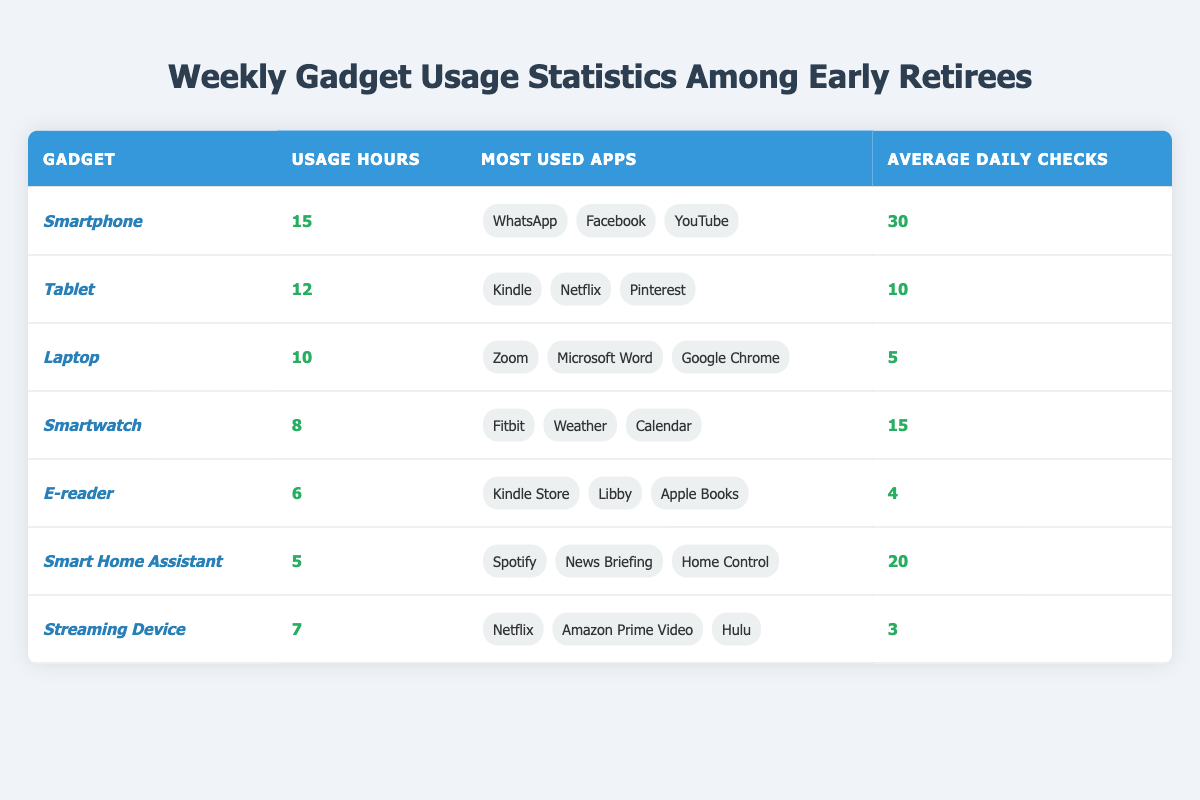What gadget has the highest usage hours? The gadget with the highest usage hours can be found in the first column of the table. Looking at the "Usage Hours" column, the smartphone has the highest value at 15 hours.
Answer: Smartphone How many average daily checks do users perform on their tablets? The average daily checks for tablets is listed in the last column of the tablet row. It shows an average of 10 daily checks for tablets.
Answer: 10 What are the most used apps for Smartwatches? The most used apps can be found in the "Most Used Apps" column for Smartwatches. The apps listed are Fitbit, Weather, and Calendar.
Answer: Fitbit, Weather, Calendar Which gadget has fewer usage hours than the Smart Home Assistant? The usage hours for Smart Home Assistant are 5. We check each gadget's usage hours, and the E-reader (6 hours) and Streaming Device (7 hours) have more hours, while the Laptop (10), Tablet (12), and Smartphone (15) have more usage hours. Only the Smart Home Assistant has fewer usage hours than 5.
Answer: No gadgets What is the total usage hours for all gadgets listed? We sum up the usage hours of all gadgets: 15 (Smartphone) + 12 (Tablet) + 10 (Laptop) + 8 (Smartwatch) + 6 (E-reader) + 5 (Smart Home Assistant) + 7 (Streaming Device) = 63 hours total.
Answer: 63 Which gadget has the lowest average daily checks, and what is that number? We look at the "Average Daily Checks" column to find the lowest number. The Streaming Device has the lowest average daily checks at 3.
Answer: Streaming Device, 3 Is it true that the most used app for the Tablet is Netflix? We check the "Most Used Apps" for the Tablet. The first app listed is Kindle, not Netflix, making the statement false.
Answer: No Calculate the average usage hours for all gadgets. The total usage hours are 63 (calculated previously). There are 7 gadgets, so we divide 63 by 7, which equals approximately 9 hours.
Answer: 9 What is the difference in average daily checks between the Smartphone and the E-reader? The average daily checks for the Smartphone are 30 and for the E-reader are 4. To find the difference, we subtract: 30 - 4 = 26.
Answer: 26 Which gadget is used for video streaming based on the most used apps? In the "Most Used Apps" column, both the Tablet and Streaming Device list apps used for video streaming, such as Netflix and Amazon Prime Video. They are video streaming gadgets.
Answer: Tablet, Streaming Device How many gadgets have an average usage of more than 10 hours? Checking the "Usage Hours" column, the Smartphone (15), Tablet (12), and Laptop (10) are those with more than 10 hours, totaling three gadgets.
Answer: 3 